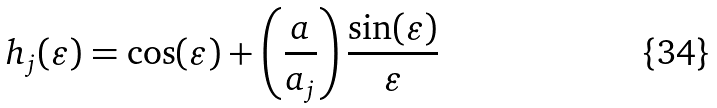<formula> <loc_0><loc_0><loc_500><loc_500>h _ { j } ( \varepsilon ) = \cos ( \varepsilon ) + \left ( \frac { a } { a _ { j } } \right ) \frac { \sin ( \varepsilon ) } { \varepsilon }</formula> 